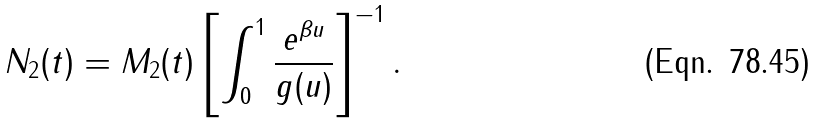Convert formula to latex. <formula><loc_0><loc_0><loc_500><loc_500>N _ { 2 } ( t ) = M _ { 2 } ( t ) \left [ \int _ { 0 } ^ { 1 } \frac { e ^ { \beta u } } { g ( u ) } \right ] ^ { - 1 } .</formula> 